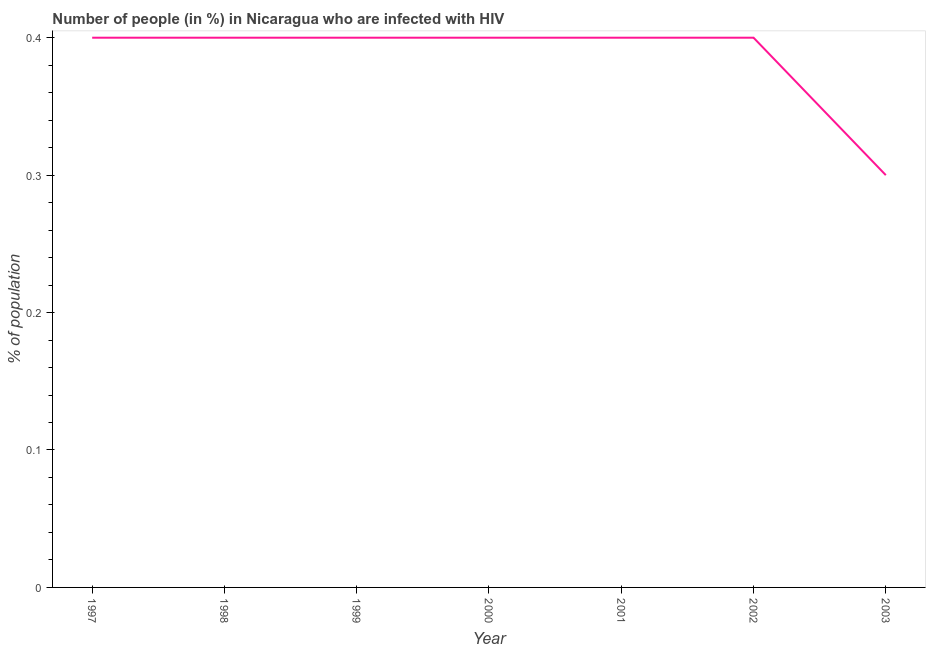What is the number of people infected with hiv in 2000?
Offer a very short reply. 0.4. Across all years, what is the minimum number of people infected with hiv?
Offer a very short reply. 0.3. What is the sum of the number of people infected with hiv?
Offer a very short reply. 2.7. What is the average number of people infected with hiv per year?
Ensure brevity in your answer.  0.39. What is the ratio of the number of people infected with hiv in 1997 to that in 2001?
Give a very brief answer. 1. Is the number of people infected with hiv in 1999 less than that in 2003?
Offer a very short reply. No. Is the difference between the number of people infected with hiv in 2001 and 2002 greater than the difference between any two years?
Make the answer very short. No. What is the difference between the highest and the second highest number of people infected with hiv?
Your answer should be compact. 0. What is the difference between the highest and the lowest number of people infected with hiv?
Provide a succinct answer. 0.1. Does the number of people infected with hiv monotonically increase over the years?
Ensure brevity in your answer.  No. How many lines are there?
Your answer should be very brief. 1. Are the values on the major ticks of Y-axis written in scientific E-notation?
Provide a short and direct response. No. Does the graph contain any zero values?
Make the answer very short. No. What is the title of the graph?
Give a very brief answer. Number of people (in %) in Nicaragua who are infected with HIV. What is the label or title of the X-axis?
Offer a very short reply. Year. What is the label or title of the Y-axis?
Offer a very short reply. % of population. What is the % of population in 1997?
Provide a succinct answer. 0.4. What is the % of population in 2001?
Provide a succinct answer. 0.4. What is the % of population of 2002?
Make the answer very short. 0.4. What is the % of population in 2003?
Give a very brief answer. 0.3. What is the difference between the % of population in 1997 and 1999?
Keep it short and to the point. 0. What is the difference between the % of population in 1997 and 2001?
Your answer should be compact. 0. What is the difference between the % of population in 1997 and 2002?
Make the answer very short. 0. What is the difference between the % of population in 1998 and 1999?
Make the answer very short. 0. What is the difference between the % of population in 1998 and 2000?
Make the answer very short. 0. What is the difference between the % of population in 1998 and 2001?
Give a very brief answer. 0. What is the difference between the % of population in 1998 and 2002?
Keep it short and to the point. 0. What is the difference between the % of population in 1998 and 2003?
Give a very brief answer. 0.1. What is the difference between the % of population in 1999 and 2000?
Offer a terse response. 0. What is the difference between the % of population in 1999 and 2002?
Offer a very short reply. 0. What is the difference between the % of population in 1999 and 2003?
Your answer should be very brief. 0.1. What is the difference between the % of population in 2000 and 2002?
Provide a short and direct response. 0. What is the difference between the % of population in 2001 and 2003?
Give a very brief answer. 0.1. What is the ratio of the % of population in 1997 to that in 1998?
Ensure brevity in your answer.  1. What is the ratio of the % of population in 1997 to that in 1999?
Provide a short and direct response. 1. What is the ratio of the % of population in 1997 to that in 2000?
Give a very brief answer. 1. What is the ratio of the % of population in 1997 to that in 2003?
Your answer should be very brief. 1.33. What is the ratio of the % of population in 1998 to that in 1999?
Provide a succinct answer. 1. What is the ratio of the % of population in 1998 to that in 2000?
Ensure brevity in your answer.  1. What is the ratio of the % of population in 1998 to that in 2001?
Give a very brief answer. 1. What is the ratio of the % of population in 1998 to that in 2002?
Provide a succinct answer. 1. What is the ratio of the % of population in 1998 to that in 2003?
Offer a very short reply. 1.33. What is the ratio of the % of population in 1999 to that in 2000?
Provide a succinct answer. 1. What is the ratio of the % of population in 1999 to that in 2001?
Provide a short and direct response. 1. What is the ratio of the % of population in 1999 to that in 2002?
Provide a succinct answer. 1. What is the ratio of the % of population in 1999 to that in 2003?
Keep it short and to the point. 1.33. What is the ratio of the % of population in 2000 to that in 2003?
Ensure brevity in your answer.  1.33. What is the ratio of the % of population in 2001 to that in 2003?
Give a very brief answer. 1.33. What is the ratio of the % of population in 2002 to that in 2003?
Make the answer very short. 1.33. 